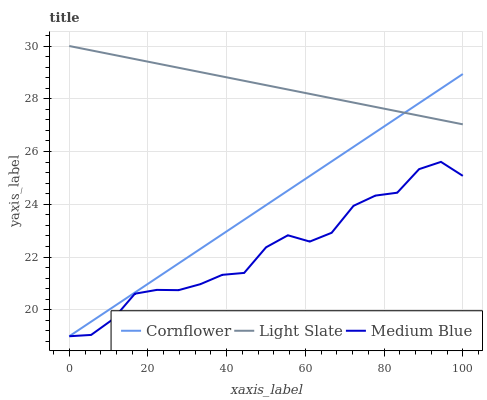Does Medium Blue have the minimum area under the curve?
Answer yes or no. Yes. Does Light Slate have the maximum area under the curve?
Answer yes or no. Yes. Does Cornflower have the minimum area under the curve?
Answer yes or no. No. Does Cornflower have the maximum area under the curve?
Answer yes or no. No. Is Cornflower the smoothest?
Answer yes or no. Yes. Is Medium Blue the roughest?
Answer yes or no. Yes. Is Medium Blue the smoothest?
Answer yes or no. No. Is Cornflower the roughest?
Answer yes or no. No. Does Cornflower have the lowest value?
Answer yes or no. Yes. Does Light Slate have the highest value?
Answer yes or no. Yes. Does Cornflower have the highest value?
Answer yes or no. No. Is Medium Blue less than Light Slate?
Answer yes or no. Yes. Is Light Slate greater than Medium Blue?
Answer yes or no. Yes. Does Medium Blue intersect Cornflower?
Answer yes or no. Yes. Is Medium Blue less than Cornflower?
Answer yes or no. No. Is Medium Blue greater than Cornflower?
Answer yes or no. No. Does Medium Blue intersect Light Slate?
Answer yes or no. No. 